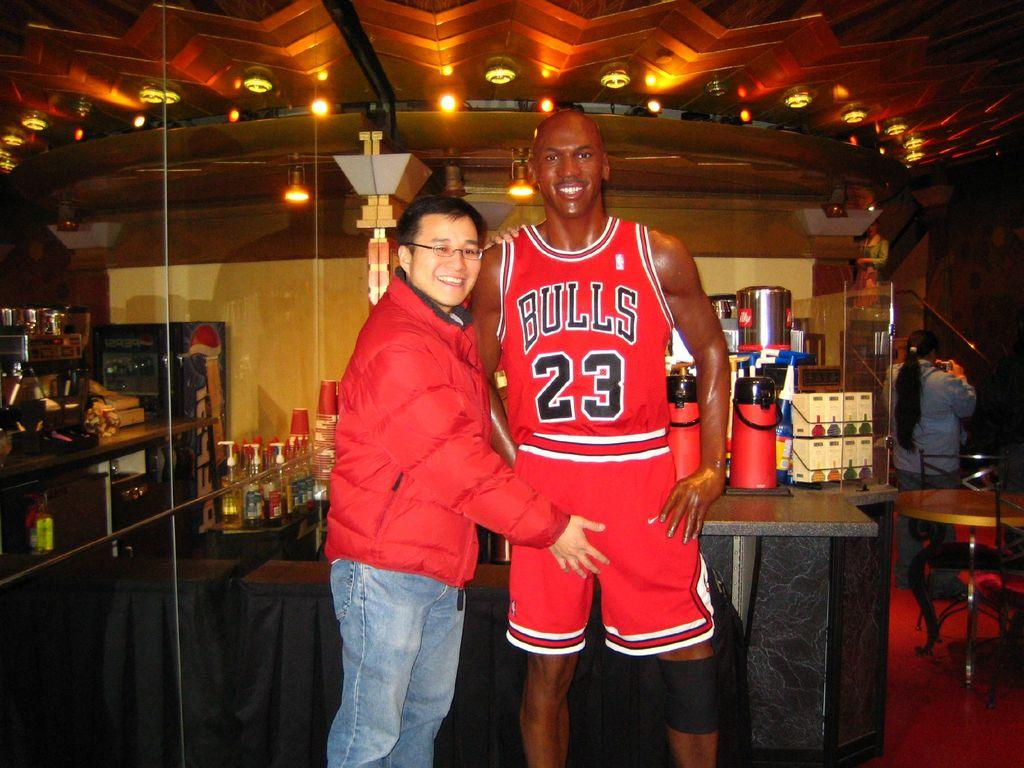Provide a one-sentence caption for the provided image. A fan has his hand on the crotch of a cardboard cutout figure of Bulls player number 23. 